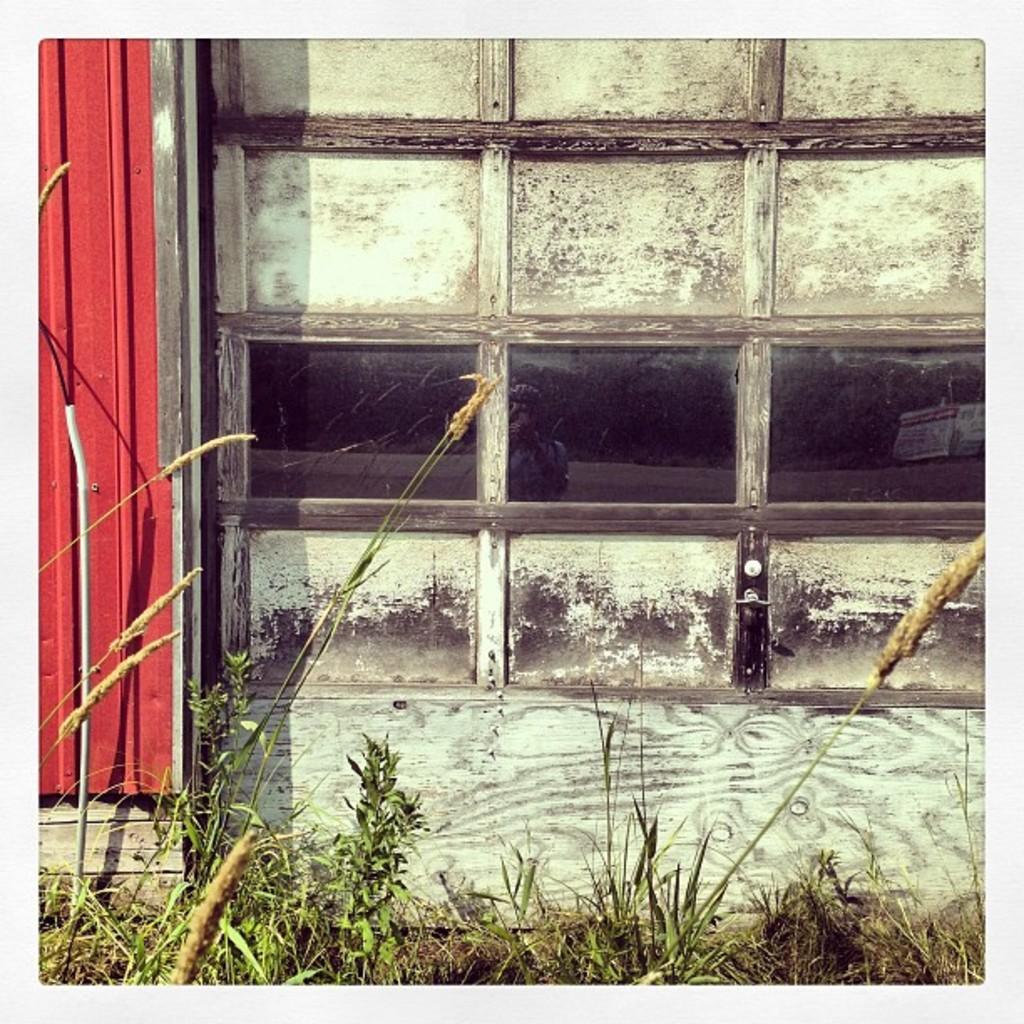Describe this image in one or two sentences. In the center of the image we can see the wooden wall, glass, red color sheet, wooden door and grass. 